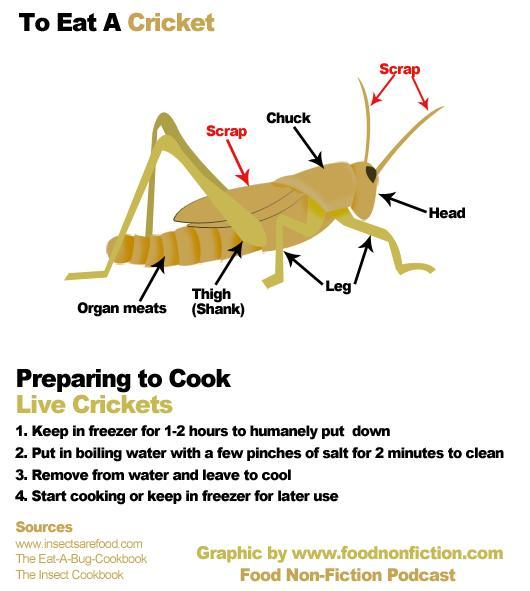Which parts of the cricket are to be removed before cooking, Leg, Chuck, Antennae, Thigh, or Wings?
Answer the question with a short phrase. Antennae, Wings 